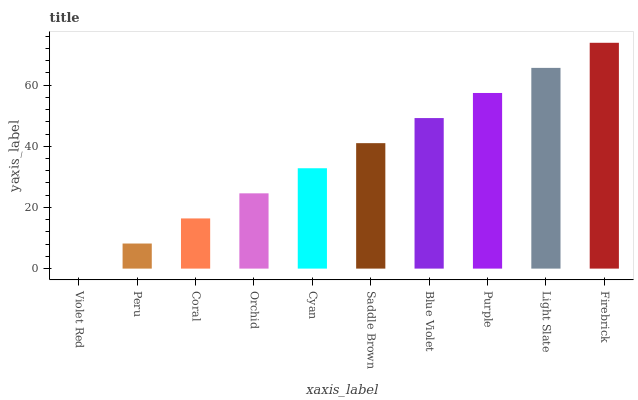Is Violet Red the minimum?
Answer yes or no. Yes. Is Firebrick the maximum?
Answer yes or no. Yes. Is Peru the minimum?
Answer yes or no. No. Is Peru the maximum?
Answer yes or no. No. Is Peru greater than Violet Red?
Answer yes or no. Yes. Is Violet Red less than Peru?
Answer yes or no. Yes. Is Violet Red greater than Peru?
Answer yes or no. No. Is Peru less than Violet Red?
Answer yes or no. No. Is Saddle Brown the high median?
Answer yes or no. Yes. Is Cyan the low median?
Answer yes or no. Yes. Is Cyan the high median?
Answer yes or no. No. Is Blue Violet the low median?
Answer yes or no. No. 